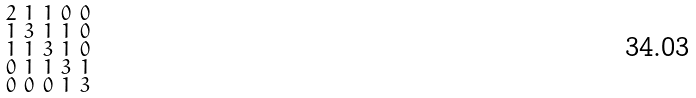Convert formula to latex. <formula><loc_0><loc_0><loc_500><loc_500>\begin{smallmatrix} 2 & 1 & 1 & 0 & 0 \\ 1 & 3 & 1 & 1 & 0 \\ 1 & 1 & 3 & 1 & 0 \\ 0 & 1 & 1 & 3 & 1 \\ 0 & 0 & 0 & 1 & 3 \end{smallmatrix}</formula> 